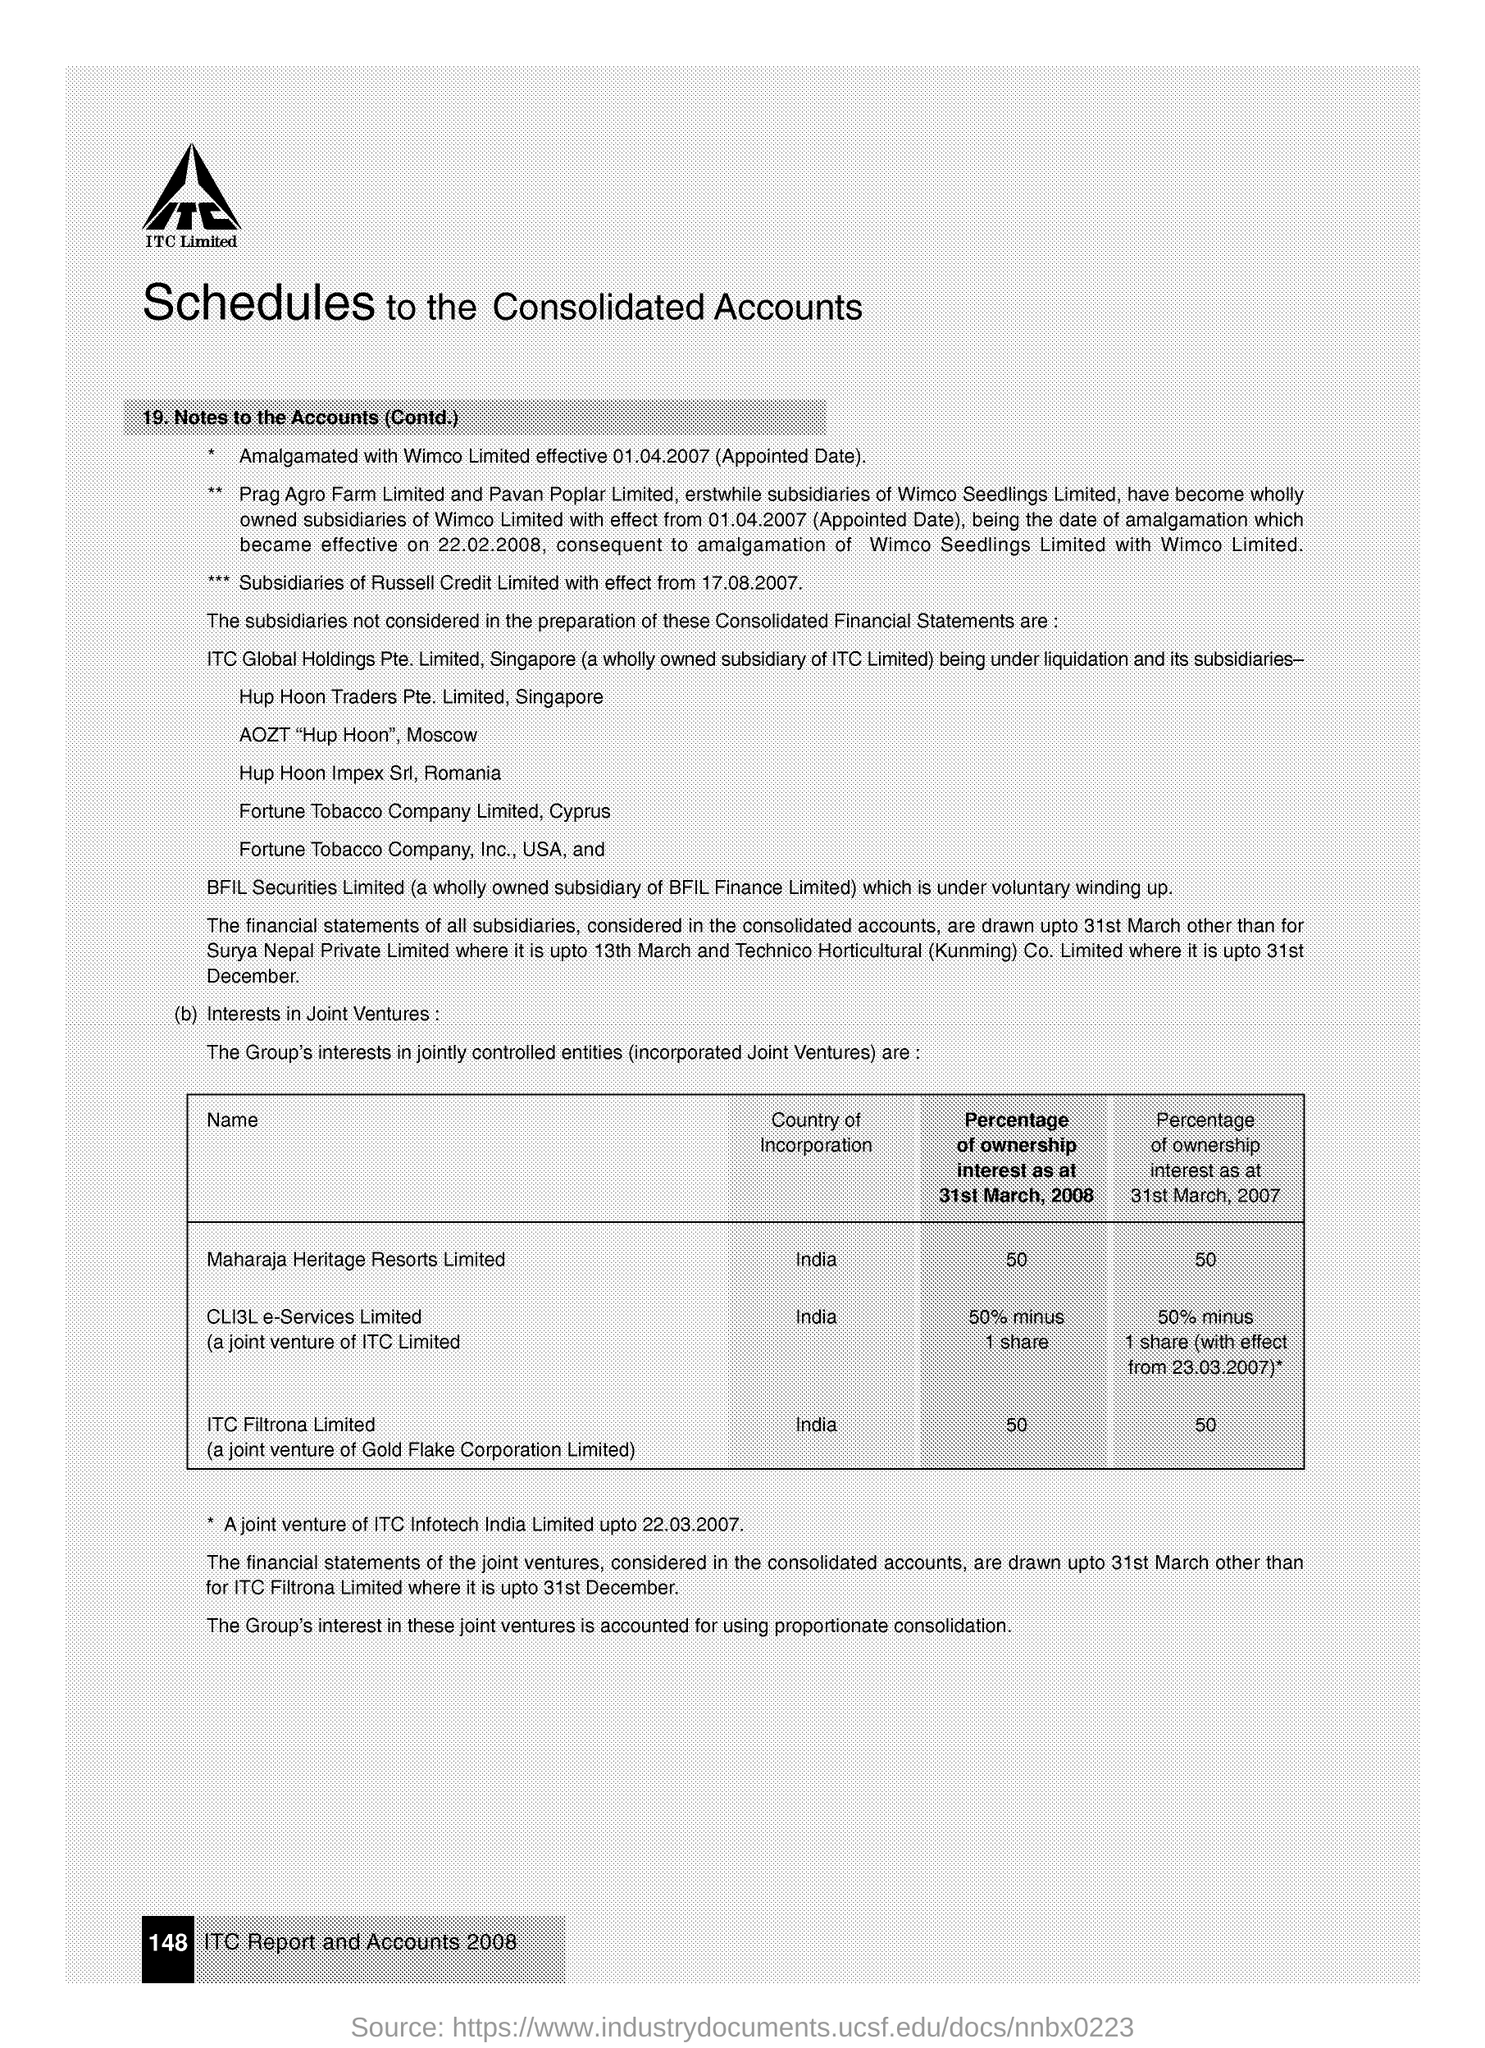Give some essential details in this illustration. The percentage of ownership interest of Maharaja Heritage Resorts Limited for the year 2008 was 50%. ITC Filtrona Limited held 50% ownership interest in the year 2008. In the year 2007, Maharaja Heritage Resorts Limited held a 50% ownership interest in the company. ITC Filtrona Limited held a 50% ownership interest in the year 2007. The joint venture of Gold Flake Corporation Limited and ITC Filtrona Limited is called [company name]. 